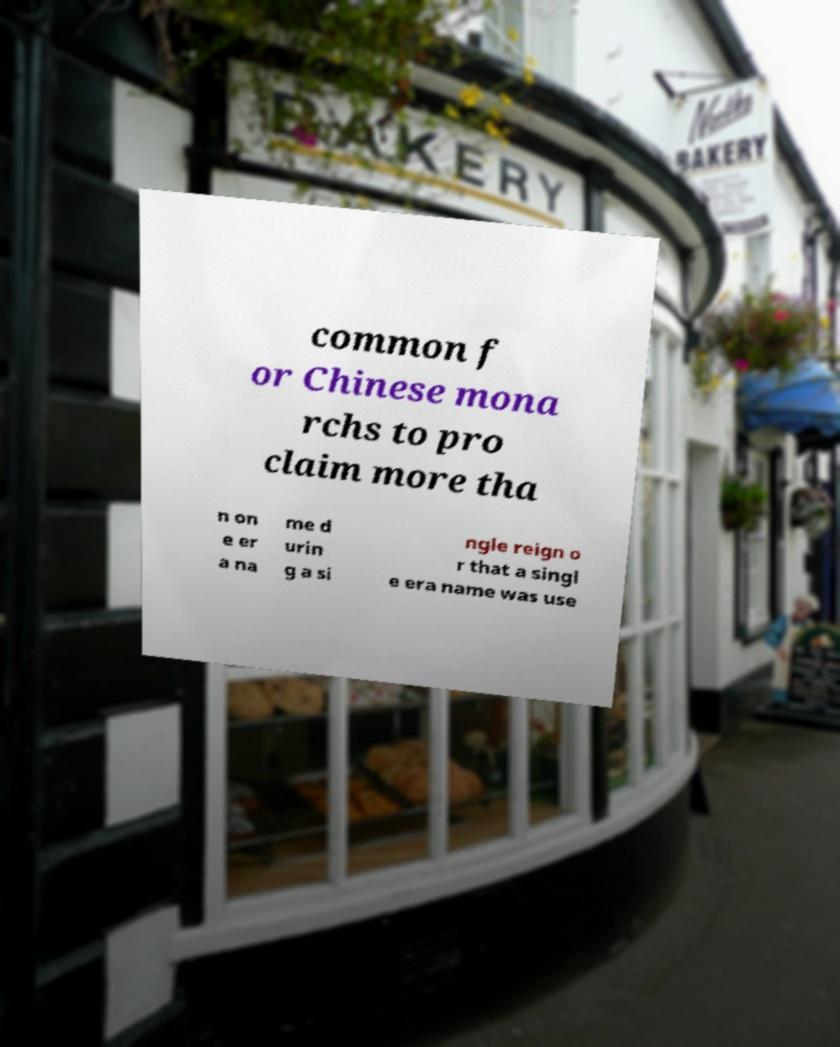Please read and relay the text visible in this image. What does it say? common f or Chinese mona rchs to pro claim more tha n on e er a na me d urin g a si ngle reign o r that a singl e era name was use 